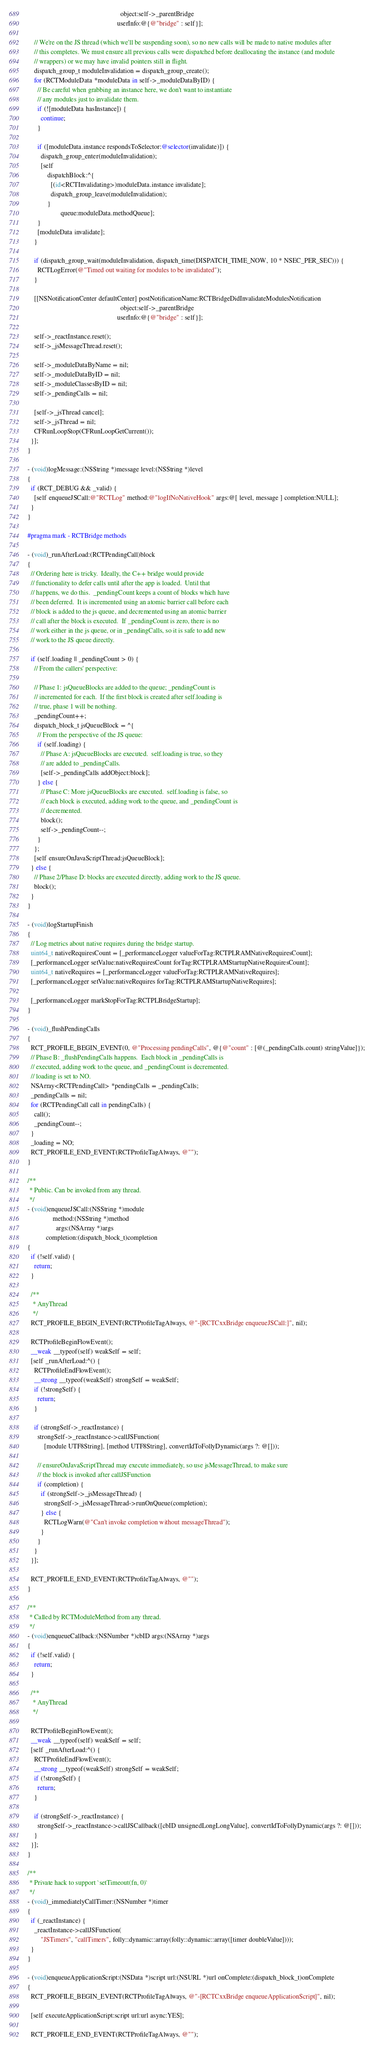<code> <loc_0><loc_0><loc_500><loc_500><_ObjectiveC_>                                                        object:self->_parentBridge
                                                      userInfo:@{@"bridge" : self}];

    // We're on the JS thread (which we'll be suspending soon), so no new calls will be made to native modules after
    // this completes. We must ensure all previous calls were dispatched before deallocating the instance (and module
    // wrappers) or we may have invalid pointers still in flight.
    dispatch_group_t moduleInvalidation = dispatch_group_create();
    for (RCTModuleData *moduleData in self->_moduleDataByID) {
      // Be careful when grabbing an instance here, we don't want to instantiate
      // any modules just to invalidate them.
      if (![moduleData hasInstance]) {
        continue;
      }

      if ([moduleData.instance respondsToSelector:@selector(invalidate)]) {
        dispatch_group_enter(moduleInvalidation);
        [self
            dispatchBlock:^{
              [(id<RCTInvalidating>)moduleData.instance invalidate];
              dispatch_group_leave(moduleInvalidation);
            }
                    queue:moduleData.methodQueue];
      }
      [moduleData invalidate];
    }

    if (dispatch_group_wait(moduleInvalidation, dispatch_time(DISPATCH_TIME_NOW, 10 * NSEC_PER_SEC))) {
      RCTLogError(@"Timed out waiting for modules to be invalidated");
    }

    [[NSNotificationCenter defaultCenter] postNotificationName:RCTBridgeDidInvalidateModulesNotification
                                                        object:self->_parentBridge
                                                      userInfo:@{@"bridge" : self}];

    self->_reactInstance.reset();
    self->_jsMessageThread.reset();

    self->_moduleDataByName = nil;
    self->_moduleDataByID = nil;
    self->_moduleClassesByID = nil;
    self->_pendingCalls = nil;

    [self->_jsThread cancel];
    self->_jsThread = nil;
    CFRunLoopStop(CFRunLoopGetCurrent());
  }];
}

- (void)logMessage:(NSString *)message level:(NSString *)level
{
  if (RCT_DEBUG && _valid) {
    [self enqueueJSCall:@"RCTLog" method:@"logIfNoNativeHook" args:@[ level, message ] completion:NULL];
  }
}

#pragma mark - RCTBridge methods

- (void)_runAfterLoad:(RCTPendingCall)block
{
  // Ordering here is tricky.  Ideally, the C++ bridge would provide
  // functionality to defer calls until after the app is loaded.  Until that
  // happens, we do this.  _pendingCount keeps a count of blocks which have
  // been deferred.  It is incremented using an atomic barrier call before each
  // block is added to the js queue, and decremented using an atomic barrier
  // call after the block is executed.  If _pendingCount is zero, there is no
  // work either in the js queue, or in _pendingCalls, so it is safe to add new
  // work to the JS queue directly.

  if (self.loading || _pendingCount > 0) {
    // From the callers' perspective:

    // Phase 1: jsQueueBlocks are added to the queue; _pendingCount is
    // incremented for each.  If the first block is created after self.loading is
    // true, phase 1 will be nothing.
    _pendingCount++;
    dispatch_block_t jsQueueBlock = ^{
      // From the perspective of the JS queue:
      if (self.loading) {
        // Phase A: jsQueueBlocks are executed.  self.loading is true, so they
        // are added to _pendingCalls.
        [self->_pendingCalls addObject:block];
      } else {
        // Phase C: More jsQueueBlocks are executed.  self.loading is false, so
        // each block is executed, adding work to the queue, and _pendingCount is
        // decremented.
        block();
        self->_pendingCount--;
      }
    };
    [self ensureOnJavaScriptThread:jsQueueBlock];
  } else {
    // Phase 2/Phase D: blocks are executed directly, adding work to the JS queue.
    block();
  }
}

- (void)logStartupFinish
{
  // Log metrics about native requires during the bridge startup.
  uint64_t nativeRequiresCount = [_performanceLogger valueForTag:RCTPLRAMNativeRequiresCount];
  [_performanceLogger setValue:nativeRequiresCount forTag:RCTPLRAMStartupNativeRequiresCount];
  uint64_t nativeRequires = [_performanceLogger valueForTag:RCTPLRAMNativeRequires];
  [_performanceLogger setValue:nativeRequires forTag:RCTPLRAMStartupNativeRequires];

  [_performanceLogger markStopForTag:RCTPLBridgeStartup];
}

- (void)_flushPendingCalls
{
  RCT_PROFILE_BEGIN_EVENT(0, @"Processing pendingCalls", @{@"count" : [@(_pendingCalls.count) stringValue]});
  // Phase B: _flushPendingCalls happens.  Each block in _pendingCalls is
  // executed, adding work to the queue, and _pendingCount is decremented.
  // loading is set to NO.
  NSArray<RCTPendingCall> *pendingCalls = _pendingCalls;
  _pendingCalls = nil;
  for (RCTPendingCall call in pendingCalls) {
    call();
    _pendingCount--;
  }
  _loading = NO;
  RCT_PROFILE_END_EVENT(RCTProfileTagAlways, @"");
}

/**
 * Public. Can be invoked from any thread.
 */
- (void)enqueueJSCall:(NSString *)module
               method:(NSString *)method
                 args:(NSArray *)args
           completion:(dispatch_block_t)completion
{
  if (!self.valid) {
    return;
  }

  /**
   * AnyThread
   */
  RCT_PROFILE_BEGIN_EVENT(RCTProfileTagAlways, @"-[RCTCxxBridge enqueueJSCall:]", nil);

  RCTProfileBeginFlowEvent();
  __weak __typeof(self) weakSelf = self;
  [self _runAfterLoad:^() {
    RCTProfileEndFlowEvent();
    __strong __typeof(weakSelf) strongSelf = weakSelf;
    if (!strongSelf) {
      return;
    }

    if (strongSelf->_reactInstance) {
      strongSelf->_reactInstance->callJSFunction(
          [module UTF8String], [method UTF8String], convertIdToFollyDynamic(args ?: @[]));

      // ensureOnJavaScriptThread may execute immediately, so use jsMessageThread, to make sure
      // the block is invoked after callJSFunction
      if (completion) {
        if (strongSelf->_jsMessageThread) {
          strongSelf->_jsMessageThread->runOnQueue(completion);
        } else {
          RCTLogWarn(@"Can't invoke completion without messageThread");
        }
      }
    }
  }];

  RCT_PROFILE_END_EVENT(RCTProfileTagAlways, @"");
}

/**
 * Called by RCTModuleMethod from any thread.
 */
- (void)enqueueCallback:(NSNumber *)cbID args:(NSArray *)args
{
  if (!self.valid) {
    return;
  }

  /**
   * AnyThread
   */

  RCTProfileBeginFlowEvent();
  __weak __typeof(self) weakSelf = self;
  [self _runAfterLoad:^() {
    RCTProfileEndFlowEvent();
    __strong __typeof(weakSelf) strongSelf = weakSelf;
    if (!strongSelf) {
      return;
    }

    if (strongSelf->_reactInstance) {
      strongSelf->_reactInstance->callJSCallback([cbID unsignedLongLongValue], convertIdToFollyDynamic(args ?: @[]));
    }
  }];
}

/**
 * Private hack to support `setTimeout(fn, 0)`
 */
- (void)_immediatelyCallTimer:(NSNumber *)timer
{
  if (_reactInstance) {
    _reactInstance->callJSFunction(
        "JSTimers", "callTimers", folly::dynamic::array(folly::dynamic::array([timer doubleValue])));
  }
}

- (void)enqueueApplicationScript:(NSData *)script url:(NSURL *)url onComplete:(dispatch_block_t)onComplete
{
  RCT_PROFILE_BEGIN_EVENT(RCTProfileTagAlways, @"-[RCTCxxBridge enqueueApplicationScript]", nil);

  [self executeApplicationScript:script url:url async:YES];

  RCT_PROFILE_END_EVENT(RCTProfileTagAlways, @"");
</code> 